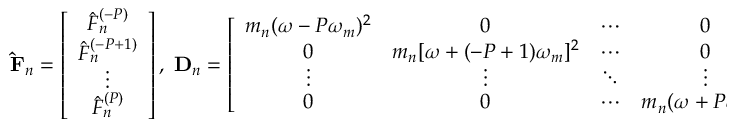Convert formula to latex. <formula><loc_0><loc_0><loc_500><loc_500>\hat { F } _ { n } = \left [ \begin{array} { c } { \hat { F } _ { n } ^ { ( - P ) } } \\ { \hat { F } _ { n } ^ { ( - P + 1 ) } } \\ { \vdots } \\ { \hat { F } _ { n } ^ { ( P ) } } \end{array} \right ] , \, D _ { n } = \left [ \begin{array} { c c c c } { m _ { n } ( \omega - P \omega _ { m } ) ^ { 2 } } & { 0 } & { \cdots } & { 0 } \\ { 0 } & { m _ { n } [ \omega + ( - P + 1 ) \omega _ { m } ] ^ { 2 } } & { \cdots } & { 0 } \\ { \vdots } & { \vdots } & { \ddots } & { \vdots } \\ { 0 } & { 0 } & { \cdots } & { m _ { n } ( \omega + P \omega _ { m } ) ^ { 2 } } \end{array} \right ] .</formula> 